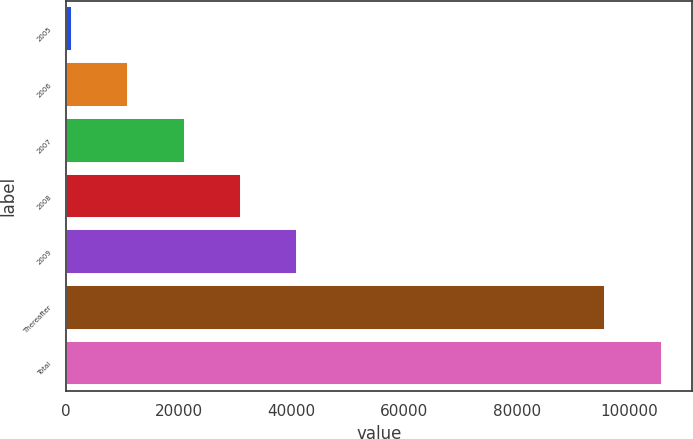Convert chart. <chart><loc_0><loc_0><loc_500><loc_500><bar_chart><fcel>2005<fcel>2006<fcel>2007<fcel>2008<fcel>2009<fcel>Thereafter<fcel>Total<nl><fcel>1037<fcel>11046<fcel>21055<fcel>31064<fcel>41073<fcel>95725<fcel>105734<nl></chart> 